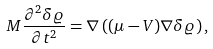Convert formula to latex. <formula><loc_0><loc_0><loc_500><loc_500>M \frac { \partial ^ { 2 } \delta \varrho } { \partial t ^ { 2 } } = \nabla \left ( ( \mu - V ) \nabla \delta \varrho \right ) ,</formula> 